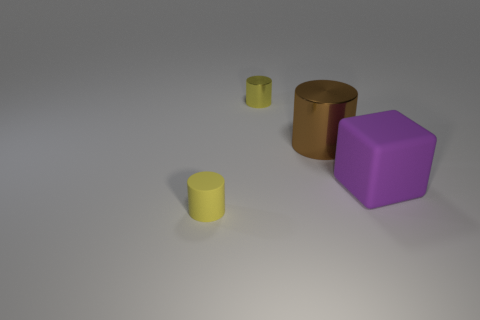Add 2 large things. How many objects exist? 6 Subtract all blocks. How many objects are left? 3 Subtract all small yellow matte cylinders. Subtract all big metallic objects. How many objects are left? 2 Add 3 brown shiny objects. How many brown shiny objects are left? 4 Add 3 tiny objects. How many tiny objects exist? 5 Subtract 0 cyan cubes. How many objects are left? 4 